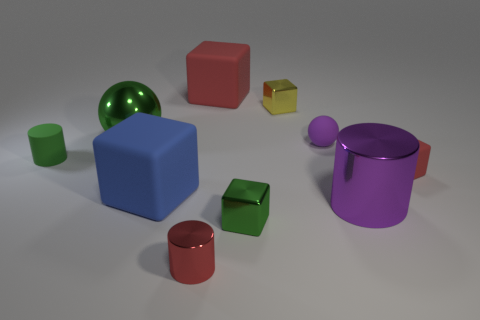There is a cylinder that is both to the right of the tiny green matte thing and left of the tiny yellow metallic object; what is its color?
Make the answer very short. Red. There is a metal ball; are there any tiny cylinders to the right of it?
Ensure brevity in your answer.  Yes. There is a big matte block on the right side of the red cylinder; how many tiny red cylinders are behind it?
Give a very brief answer. 0. What size is the purple sphere that is the same material as the blue object?
Your response must be concise. Small. What is the size of the green metal sphere?
Provide a succinct answer. Large. Does the red cylinder have the same material as the tiny yellow cube?
Offer a very short reply. Yes. What number of cubes are tiny green metallic objects or matte things?
Make the answer very short. 4. There is a small block that is to the right of the cylinder that is to the right of the purple rubber thing; what is its color?
Keep it short and to the point. Red. What size is the rubber thing that is the same color as the tiny matte cube?
Your answer should be compact. Large. What number of green things are on the right side of the red block that is to the right of the small shiny thing behind the purple matte sphere?
Keep it short and to the point. 0. 